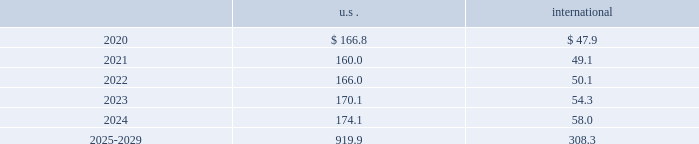The descriptions and fair value methodologies for the u.s .
And international pension plan assets are as follows : cash and cash equivalents the carrying amounts of cash and cash equivalents approximate fair value due to the short-term maturity .
Equity securities equity securities are valued at the closing market price reported on a u.s .
Or international exchange where the security is actively traded and are therefore classified as level 1 assets .
Equity mutual and pooled funds shares of mutual funds are valued at the nav of the fund and are classified as level 1 assets .
Units of pooled funds are valued at the per unit nav determined by the fund manager based on the value of the underlying traded holdings and are classified as level 2 assets .
Corporate and government bonds corporate and government bonds are classified as level 2 assets , as they are either valued at quoted market prices from observable pricing sources at the reporting date or valued based upon comparable securities with similar yields and credit ratings .
Other pooled funds other pooled funds classified as level 2 assets are valued at the nav of the shares held at year end , which is based on the fair value of the underlying investments .
Securities and interests classified as level 3 assets are carried at the estimated fair value .
The estimated fair value is based on the fair value of the underlying investment values , which includes estimated bids from brokers or other third-party vendor sources that utilize expected cash flow streams and other uncorroborated data including counterparty credit quality , default risk , discount rates , and the overall capital market liquidity .
Insurance contracts insurance contracts are classified as level 3 assets , as they are carried at contract value , which approximates the estimated fair value .
The estimated fair value is based on the fair value of the underlying investment of the insurance company and discount rates that require inputs with limited observability .
Contributions and projected benefit payments pension contributions to funded plans and benefit payments for unfunded plans for fiscal year 2019 were $ 40.2 .
Contributions for funded plans resulted primarily from contractual and regulatory requirements .
Benefit payments to unfunded plans were due primarily to the timing of retirements .
We anticipate contributing $ 30 to $ 40 to the defined benefit pension plans in fiscal year 2020 .
These contributions are anticipated to be driven primarily by contractual and regulatory requirements for funded plans and benefit payments for unfunded plans , which are dependent upon timing of retirements .
Projected benefit payments , which reflect expected future service , are as follows: .
These estimated benefit payments are based on assumptions about future events .
Actual benefit payments may vary significantly from these estimates. .
Considering the international projected benefit payments , what is the average yearly projection of the 2025-2029 period? 
Rationale: it is the sum of all projected benefit payments during 2025-2029 divided by 5 ( number of years ) .
Computations: (308.3 / 5)
Answer: 61.66. 